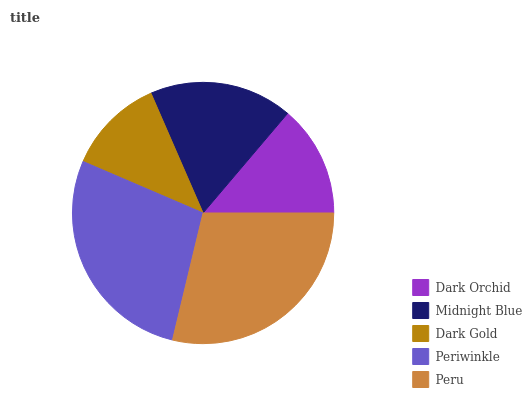Is Dark Gold the minimum?
Answer yes or no. Yes. Is Peru the maximum?
Answer yes or no. Yes. Is Midnight Blue the minimum?
Answer yes or no. No. Is Midnight Blue the maximum?
Answer yes or no. No. Is Midnight Blue greater than Dark Orchid?
Answer yes or no. Yes. Is Dark Orchid less than Midnight Blue?
Answer yes or no. Yes. Is Dark Orchid greater than Midnight Blue?
Answer yes or no. No. Is Midnight Blue less than Dark Orchid?
Answer yes or no. No. Is Midnight Blue the high median?
Answer yes or no. Yes. Is Midnight Blue the low median?
Answer yes or no. Yes. Is Dark Gold the high median?
Answer yes or no. No. Is Dark Orchid the low median?
Answer yes or no. No. 